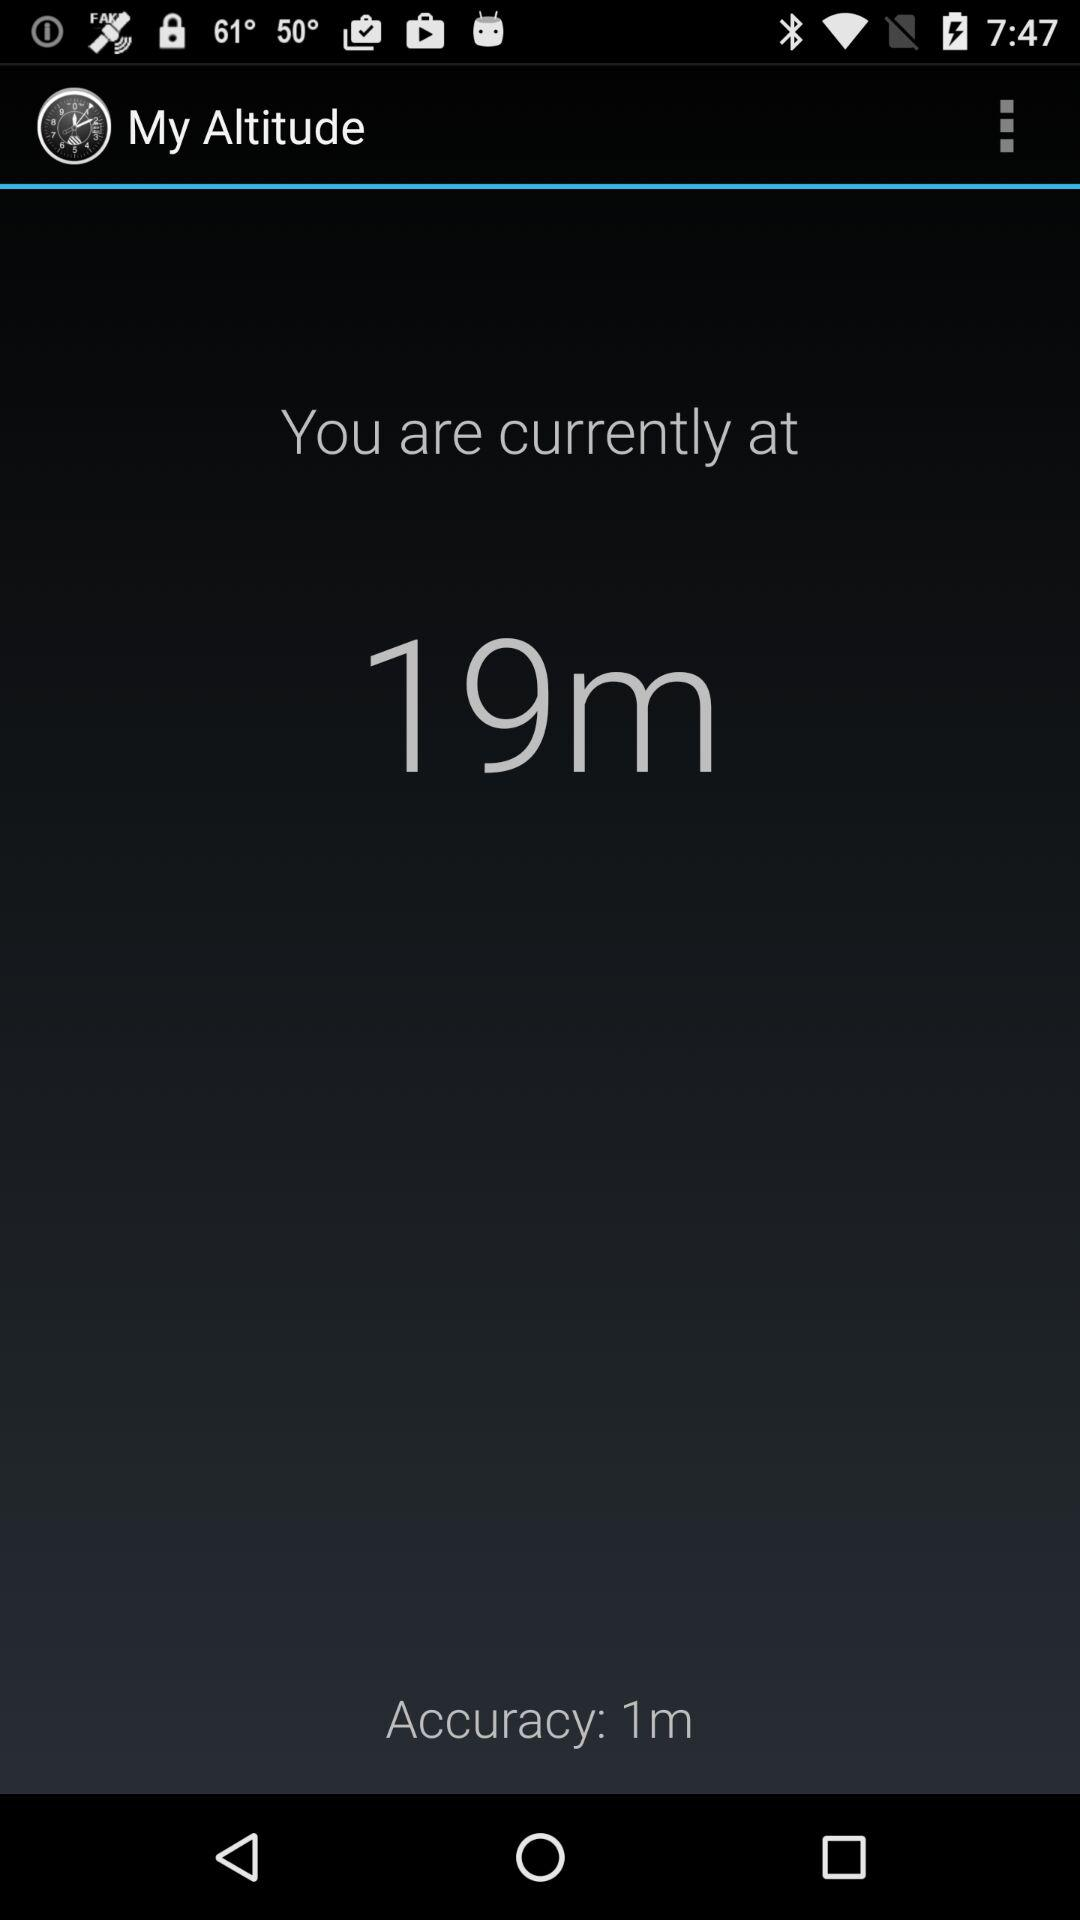How accurate is my altitude reading?
Answer the question using a single word or phrase. 1m 